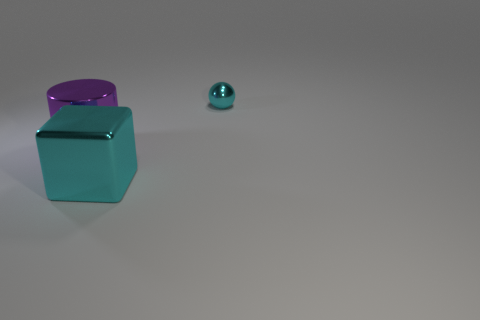Does the large purple shiny thing have the same shape as the tiny thing?
Offer a terse response. No. What material is the cyan cube that is right of the large purple metallic object?
Offer a terse response. Metal. What color is the shiny cylinder?
Make the answer very short. Purple. Do the object behind the big purple thing and the cyan object in front of the purple cylinder have the same size?
Offer a very short reply. No. How big is the shiny object that is both behind the cyan cube and to the right of the cylinder?
Provide a succinct answer. Small. Is the number of tiny cyan things on the left side of the small metal object greater than the number of large cyan blocks that are behind the purple shiny cylinder?
Your response must be concise. No. How many other objects are the same shape as the big purple metallic thing?
Your answer should be compact. 0. Are there any cubes behind the large shiny object right of the big purple cylinder?
Your answer should be compact. No. How many purple things are there?
Keep it short and to the point. 1. Do the small object and the big metallic thing in front of the large purple cylinder have the same color?
Your response must be concise. Yes. 